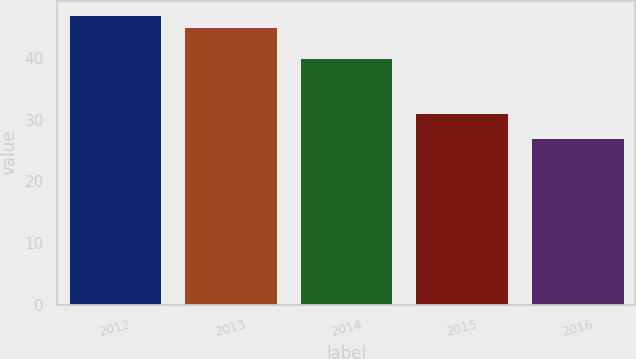Convert chart. <chart><loc_0><loc_0><loc_500><loc_500><bar_chart><fcel>2012<fcel>2013<fcel>2014<fcel>2015<fcel>2016<nl><fcel>46.9<fcel>45<fcel>40<fcel>31<fcel>27<nl></chart> 